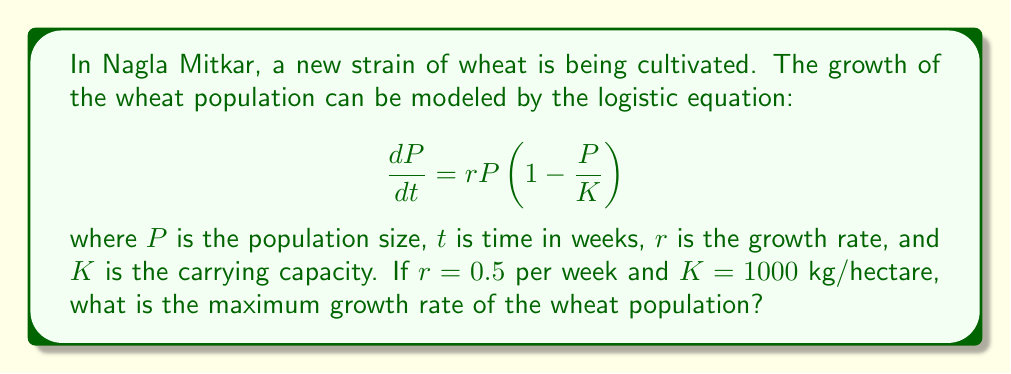What is the answer to this math problem? To find the maximum growth rate, we need to follow these steps:

1) The logistic equation is given by:

   $$\frac{dP}{dt} = rP\left(1 - \frac{P}{K}\right)$$

2) The maximum growth rate occurs when the population is at half the carrying capacity. This is because the logistic curve is symmetrical, with its inflection point at $P = K/2$.

3) Let's substitute $P = K/2$ into the equation:

   $$\frac{dP}{dt} = r\frac{K}{2}\left(1 - \frac{K/2}{K}\right)$$

4) Simplify:

   $$\frac{dP}{dt} = r\frac{K}{2}\left(1 - \frac{1}{2}\right) = r\frac{K}{2} \cdot \frac{1}{2} = r\frac{K}{4}$$

5) Now, substitute the given values $r = 0.5$ and $K = 1000$:

   $$\frac{dP}{dt} = 0.5 \cdot \frac{1000}{4} = 125$$

Therefore, the maximum growth rate is 125 kg per hectare per week.
Answer: 125 kg/hectare/week 